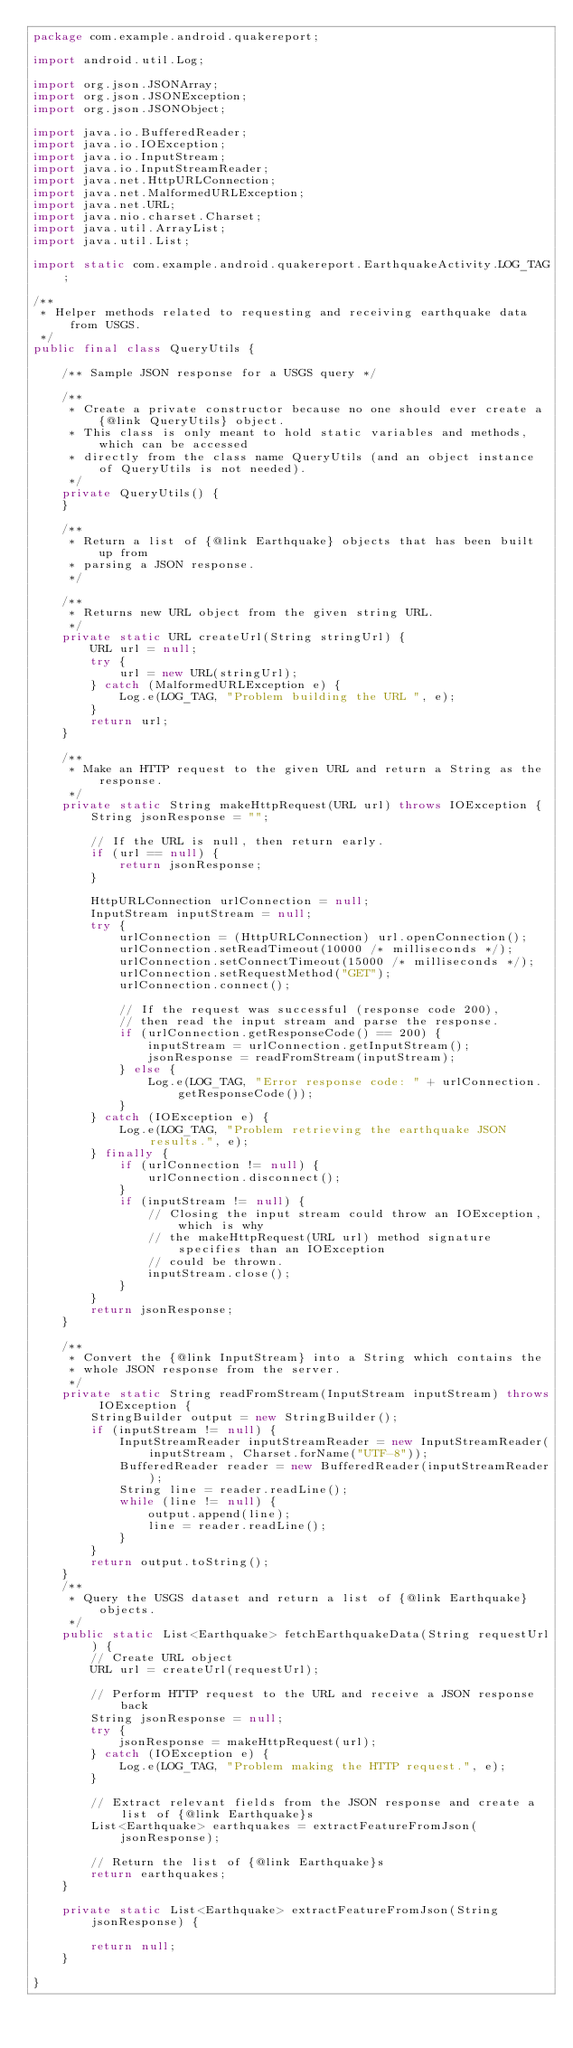<code> <loc_0><loc_0><loc_500><loc_500><_Java_>package com.example.android.quakereport;

import android.util.Log;

import org.json.JSONArray;
import org.json.JSONException;
import org.json.JSONObject;

import java.io.BufferedReader;
import java.io.IOException;
import java.io.InputStream;
import java.io.InputStreamReader;
import java.net.HttpURLConnection;
import java.net.MalformedURLException;
import java.net.URL;
import java.nio.charset.Charset;
import java.util.ArrayList;
import java.util.List;

import static com.example.android.quakereport.EarthquakeActivity.LOG_TAG;

/**
 * Helper methods related to requesting and receiving earthquake data from USGS.
 */
public final class QueryUtils {

    /** Sample JSON response for a USGS query */

    /**
     * Create a private constructor because no one should ever create a {@link QueryUtils} object.
     * This class is only meant to hold static variables and methods, which can be accessed
     * directly from the class name QueryUtils (and an object instance of QueryUtils is not needed).
     */
    private QueryUtils() {
    }

    /**
     * Return a list of {@link Earthquake} objects that has been built up from
     * parsing a JSON response.
     */

    /**
     * Returns new URL object from the given string URL.
     */
    private static URL createUrl(String stringUrl) {
        URL url = null;
        try {
            url = new URL(stringUrl);
        } catch (MalformedURLException e) {
            Log.e(LOG_TAG, "Problem building the URL ", e);
        }
        return url;
    }

    /**
     * Make an HTTP request to the given URL and return a String as the response.
     */
    private static String makeHttpRequest(URL url) throws IOException {
        String jsonResponse = "";

        // If the URL is null, then return early.
        if (url == null) {
            return jsonResponse;
        }

        HttpURLConnection urlConnection = null;
        InputStream inputStream = null;
        try {
            urlConnection = (HttpURLConnection) url.openConnection();
            urlConnection.setReadTimeout(10000 /* milliseconds */);
            urlConnection.setConnectTimeout(15000 /* milliseconds */);
            urlConnection.setRequestMethod("GET");
            urlConnection.connect();

            // If the request was successful (response code 200),
            // then read the input stream and parse the response.
            if (urlConnection.getResponseCode() == 200) {
                inputStream = urlConnection.getInputStream();
                jsonResponse = readFromStream(inputStream);
            } else {
                Log.e(LOG_TAG, "Error response code: " + urlConnection.getResponseCode());
            }
        } catch (IOException e) {
            Log.e(LOG_TAG, "Problem retrieving the earthquake JSON results.", e);
        } finally {
            if (urlConnection != null) {
                urlConnection.disconnect();
            }
            if (inputStream != null) {
                // Closing the input stream could throw an IOException, which is why
                // the makeHttpRequest(URL url) method signature specifies than an IOException
                // could be thrown.
                inputStream.close();
            }
        }
        return jsonResponse;
    }

    /**
     * Convert the {@link InputStream} into a String which contains the
     * whole JSON response from the server.
     */
    private static String readFromStream(InputStream inputStream) throws IOException {
        StringBuilder output = new StringBuilder();
        if (inputStream != null) {
            InputStreamReader inputStreamReader = new InputStreamReader(inputStream, Charset.forName("UTF-8"));
            BufferedReader reader = new BufferedReader(inputStreamReader);
            String line = reader.readLine();
            while (line != null) {
                output.append(line);
                line = reader.readLine();
            }
        }
        return output.toString();
    }
    /**
     * Query the USGS dataset and return a list of {@link Earthquake} objects.
     */
    public static List<Earthquake> fetchEarthquakeData(String requestUrl) {
        // Create URL object
        URL url = createUrl(requestUrl);

        // Perform HTTP request to the URL and receive a JSON response back
        String jsonResponse = null;
        try {
            jsonResponse = makeHttpRequest(url);
        } catch (IOException e) {
            Log.e(LOG_TAG, "Problem making the HTTP request.", e);
        }

        // Extract relevant fields from the JSON response and create a list of {@link Earthquake}s
        List<Earthquake> earthquakes = extractFeatureFromJson(jsonResponse);

        // Return the list of {@link Earthquake}s
        return earthquakes;
    }

    private static List<Earthquake> extractFeatureFromJson(String jsonResponse) {

        return null;
    }

}</code> 